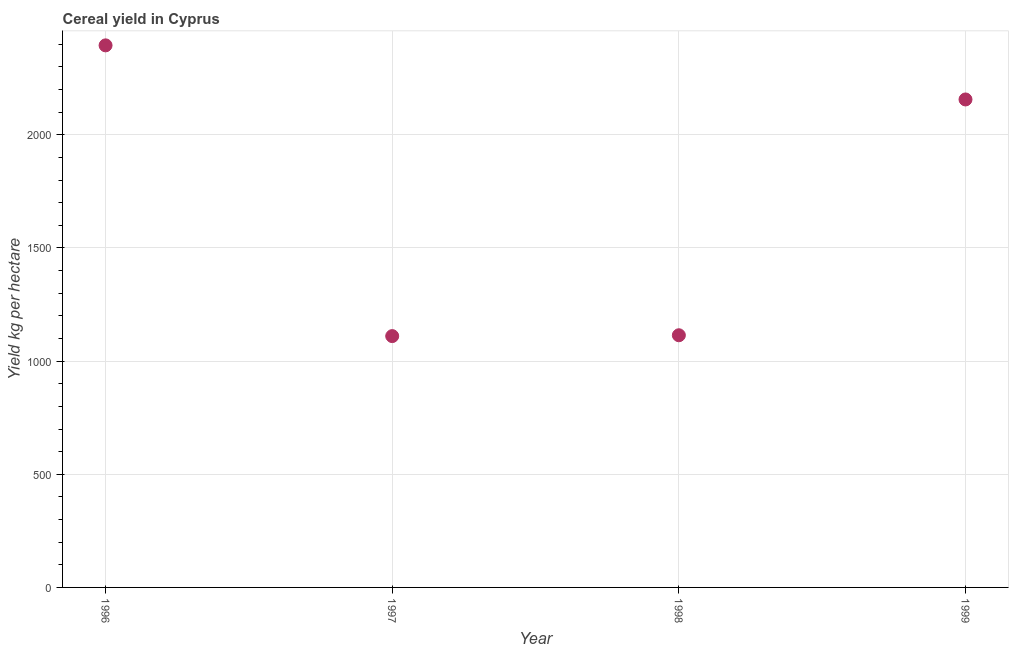What is the cereal yield in 1998?
Ensure brevity in your answer.  1114.4. Across all years, what is the maximum cereal yield?
Offer a terse response. 2395.49. Across all years, what is the minimum cereal yield?
Make the answer very short. 1110.65. What is the sum of the cereal yield?
Your answer should be very brief. 6776.97. What is the difference between the cereal yield in 1996 and 1999?
Provide a succinct answer. 239.06. What is the average cereal yield per year?
Ensure brevity in your answer.  1694.24. What is the median cereal yield?
Make the answer very short. 1635.42. In how many years, is the cereal yield greater than 1800 kg per hectare?
Keep it short and to the point. 2. Do a majority of the years between 1999 and 1998 (inclusive) have cereal yield greater than 100 kg per hectare?
Make the answer very short. No. What is the ratio of the cereal yield in 1996 to that in 1998?
Provide a short and direct response. 2.15. Is the cereal yield in 1997 less than that in 1998?
Offer a terse response. Yes. Is the difference between the cereal yield in 1996 and 1997 greater than the difference between any two years?
Give a very brief answer. Yes. What is the difference between the highest and the second highest cereal yield?
Your answer should be very brief. 239.06. Is the sum of the cereal yield in 1996 and 1999 greater than the maximum cereal yield across all years?
Your answer should be very brief. Yes. What is the difference between the highest and the lowest cereal yield?
Ensure brevity in your answer.  1284.84. Does the cereal yield monotonically increase over the years?
Offer a terse response. No. How many years are there in the graph?
Give a very brief answer. 4. What is the difference between two consecutive major ticks on the Y-axis?
Offer a terse response. 500. What is the title of the graph?
Offer a terse response. Cereal yield in Cyprus. What is the label or title of the Y-axis?
Provide a succinct answer. Yield kg per hectare. What is the Yield kg per hectare in 1996?
Offer a terse response. 2395.49. What is the Yield kg per hectare in 1997?
Offer a very short reply. 1110.65. What is the Yield kg per hectare in 1998?
Your answer should be very brief. 1114.4. What is the Yield kg per hectare in 1999?
Your answer should be compact. 2156.43. What is the difference between the Yield kg per hectare in 1996 and 1997?
Your response must be concise. 1284.84. What is the difference between the Yield kg per hectare in 1996 and 1998?
Your answer should be compact. 1281.09. What is the difference between the Yield kg per hectare in 1996 and 1999?
Provide a short and direct response. 239.06. What is the difference between the Yield kg per hectare in 1997 and 1998?
Offer a terse response. -3.76. What is the difference between the Yield kg per hectare in 1997 and 1999?
Your answer should be compact. -1045.78. What is the difference between the Yield kg per hectare in 1998 and 1999?
Your answer should be very brief. -1042.03. What is the ratio of the Yield kg per hectare in 1996 to that in 1997?
Make the answer very short. 2.16. What is the ratio of the Yield kg per hectare in 1996 to that in 1998?
Your answer should be compact. 2.15. What is the ratio of the Yield kg per hectare in 1996 to that in 1999?
Ensure brevity in your answer.  1.11. What is the ratio of the Yield kg per hectare in 1997 to that in 1999?
Offer a very short reply. 0.52. What is the ratio of the Yield kg per hectare in 1998 to that in 1999?
Keep it short and to the point. 0.52. 